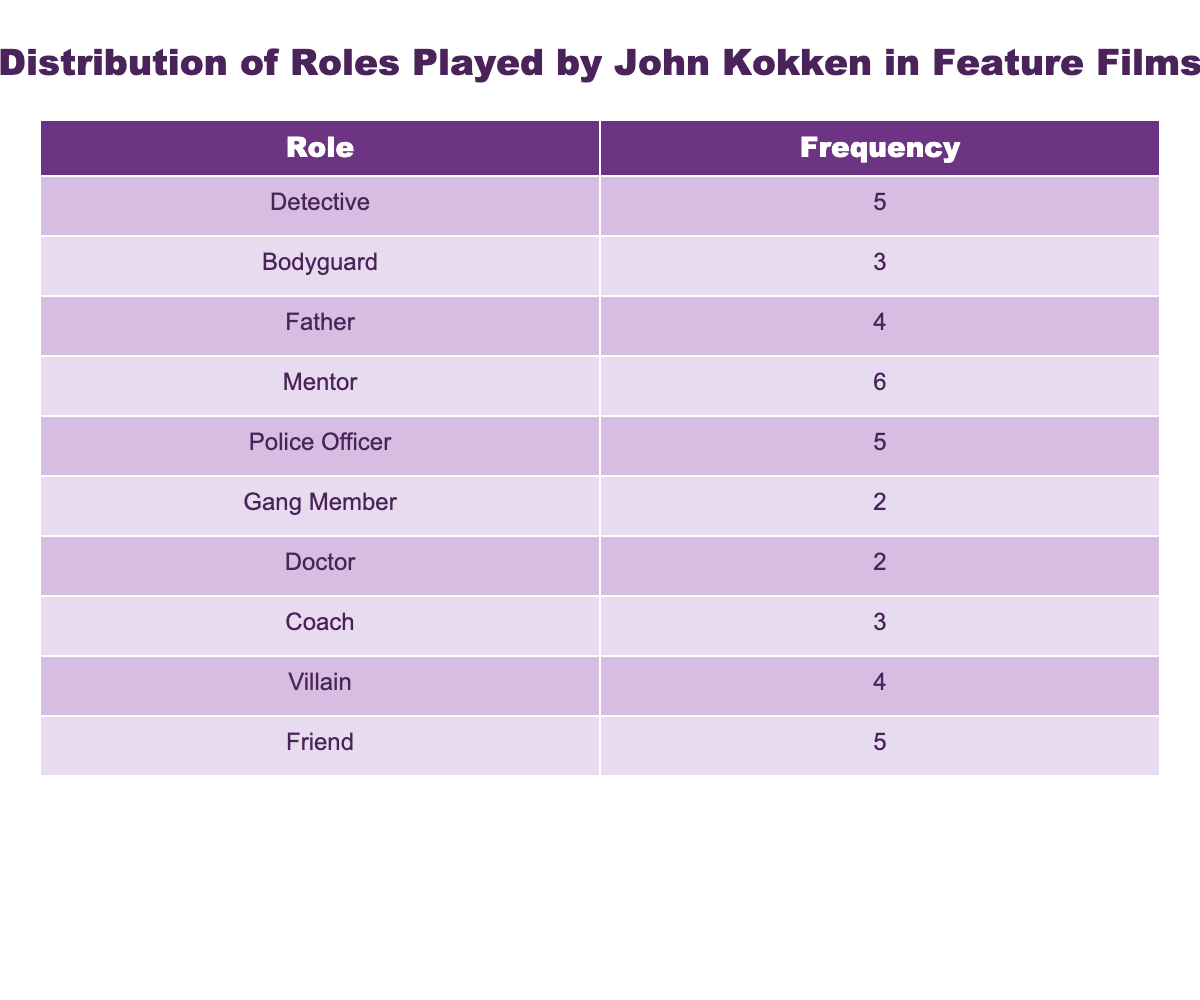What is the most frequent role played by John Kokken? The table shows the frequency of different roles played by John Kokken. By examining the "Frequency" column, we see that the role with the highest frequency is "Mentor," which occurs 6 times.
Answer: Mentor How many roles has John Kokken played that involve being a law enforcement officer? The roles related to law enforcement are "Detective" (5), "Police Officer" (5), and "Bodyguard" (3). Adding these frequencies together gives 5 + 5 + 3 = 13.
Answer: 13 What is the total number of roles played by John Kokken? To find the total number of roles, we sum the frequencies from all roles listed in the table. The calculation is 5 + 3 + 4 + 6 + 5 + 2 + 2 + 3 + 4 + 5 = 39.
Answer: 39 Is John Kokken more likely to play a villain than a coach? The frequency for the role of "Villain" is 4, while the frequency for the role of "Coach" is 3. Since 4 is greater than 3, he is indeed more likely to play a villain than a coach.
Answer: Yes What is the average frequency of roles played by John Kokken? To get the average frequency, first, we sum all the frequencies: 39, then divide by the total number of distinct roles (10). So, the average is 39 / 10 = 3.9.
Answer: 3.9 Which two roles combined have the same frequency as 'Friend'? The "Friend" role has a frequency of 5. The other roles are "Bodyguard" (3) and "Coach" (3). Their combination is "Bodyguard" + "Coach" = 3 + 3 = 6, which does not equal "Friend". Looking at others, "Father" (4) and "Villain" (4) sum to 8, "Doctor" (2) combined with "Gang Member" (2) gives 4, etc. Finally, "Detective" (5) is equal to itself—no two roles combine to 5 other than themselves.
Answer: None How many more times has John Kokken played a 'Mentor' than a 'Gang Member'? The frequency for "Mentor" is 6, and for "Gang Member" it is 2. The difference between these is calculated as 6 - 2 = 4.
Answer: 4 What percentage of John Kokken's roles are 'Detective'? The role of "Detective" has a frequency of 5 out of a total of 39. To find the percentage, we calculate (5 / 39) * 100, which equals approximately 12.82%.
Answer: Approximately 12.82% 